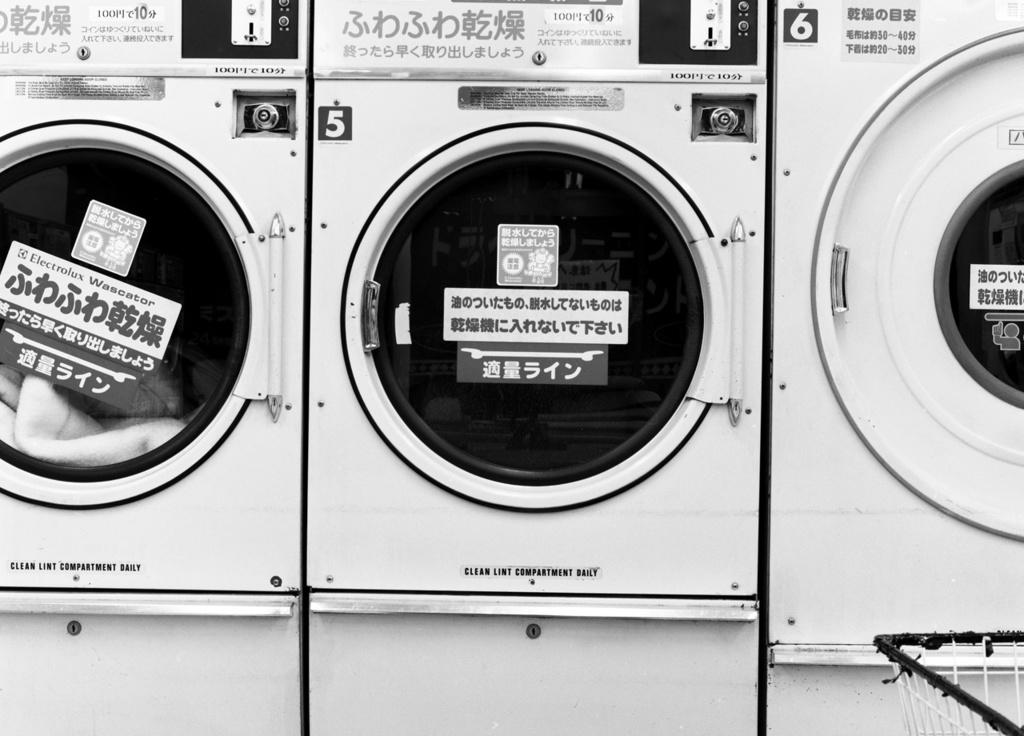What is the color scheme of the image? The image is black and white. What type of appliances can be seen in the image? There are washing machines in the image. Are there any additional details on the washing machines? Yes, there are stickers on the washing machines. How many men are leaning against the wall in the image? There are no men or walls present in the image; it features washing machines with stickers. What type of tin can be seen in the image? There is no tin present in the image. 